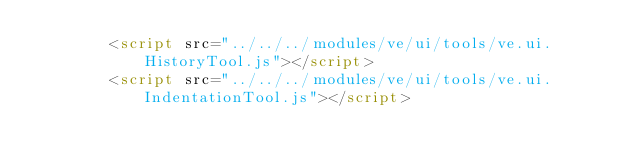<code> <loc_0><loc_0><loc_500><loc_500><_HTML_>		<script src="../../../modules/ve/ui/tools/ve.ui.HistoryTool.js"></script>
		<script src="../../../modules/ve/ui/tools/ve.ui.IndentationTool.js"></script></code> 